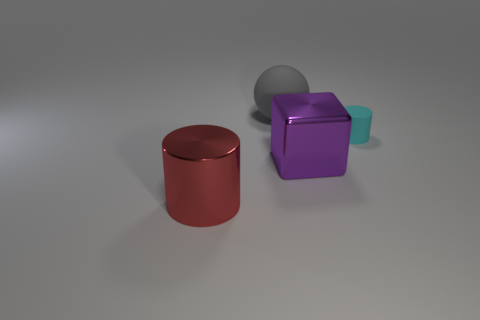Add 2 large red cylinders. How many objects exist? 6 Subtract all red cylinders. How many cylinders are left? 1 Subtract all spheres. How many objects are left? 3 Add 1 large gray balls. How many large gray balls exist? 2 Subtract 0 red cubes. How many objects are left? 4 Subtract all green blocks. Subtract all blue balls. How many blocks are left? 1 Subtract all big purple things. Subtract all small rubber objects. How many objects are left? 2 Add 3 rubber cylinders. How many rubber cylinders are left? 4 